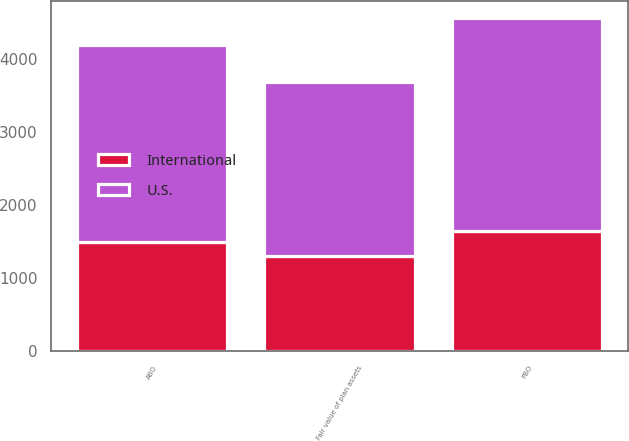Convert chart. <chart><loc_0><loc_0><loc_500><loc_500><stacked_bar_chart><ecel><fcel>PBO<fcel>Fair value of plan assets<fcel>ABO<nl><fcel>U.S.<fcel>2917.1<fcel>2386.7<fcel>2689.2<nl><fcel>International<fcel>1644.5<fcel>1299.1<fcel>1498<nl></chart> 